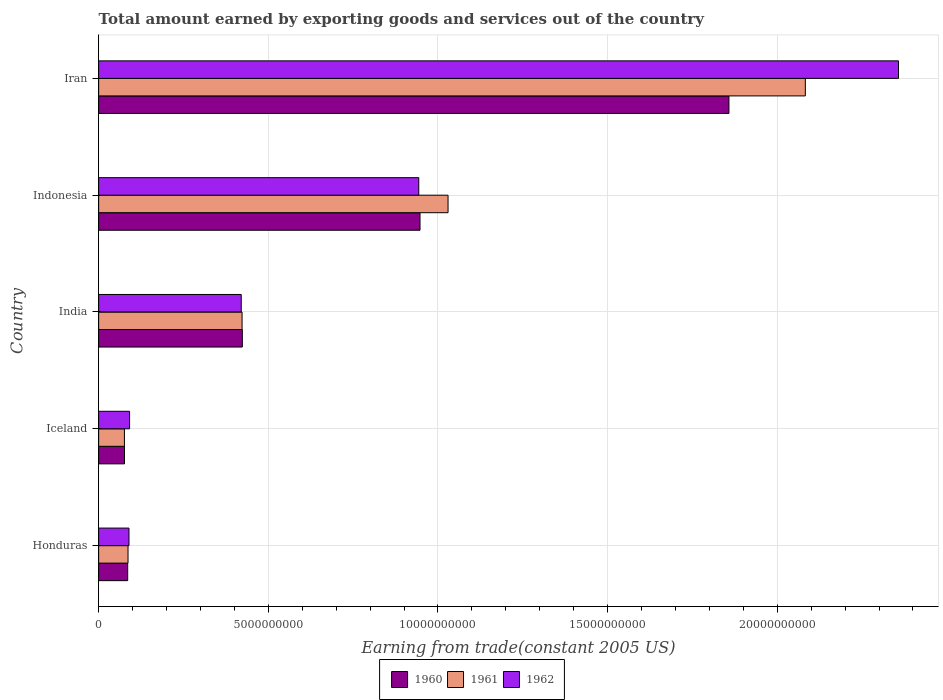Are the number of bars per tick equal to the number of legend labels?
Ensure brevity in your answer.  Yes. In how many cases, is the number of bars for a given country not equal to the number of legend labels?
Your response must be concise. 0. What is the total amount earned by exporting goods and services in 1962 in Honduras?
Provide a short and direct response. 8.95e+08. Across all countries, what is the maximum total amount earned by exporting goods and services in 1962?
Give a very brief answer. 2.36e+1. Across all countries, what is the minimum total amount earned by exporting goods and services in 1961?
Your answer should be very brief. 7.60e+08. In which country was the total amount earned by exporting goods and services in 1962 maximum?
Keep it short and to the point. Iran. What is the total total amount earned by exporting goods and services in 1960 in the graph?
Offer a terse response. 3.39e+1. What is the difference between the total amount earned by exporting goods and services in 1962 in Indonesia and that in Iran?
Provide a short and direct response. -1.41e+1. What is the difference between the total amount earned by exporting goods and services in 1960 in India and the total amount earned by exporting goods and services in 1962 in Iran?
Offer a terse response. -1.93e+1. What is the average total amount earned by exporting goods and services in 1962 per country?
Make the answer very short. 7.80e+09. What is the difference between the total amount earned by exporting goods and services in 1961 and total amount earned by exporting goods and services in 1962 in Honduras?
Offer a terse response. -2.82e+07. What is the ratio of the total amount earned by exporting goods and services in 1960 in Iceland to that in Iran?
Give a very brief answer. 0.04. Is the total amount earned by exporting goods and services in 1960 in India less than that in Iran?
Provide a succinct answer. Yes. Is the difference between the total amount earned by exporting goods and services in 1961 in Honduras and Iran greater than the difference between the total amount earned by exporting goods and services in 1962 in Honduras and Iran?
Provide a succinct answer. Yes. What is the difference between the highest and the second highest total amount earned by exporting goods and services in 1960?
Provide a short and direct response. 9.10e+09. What is the difference between the highest and the lowest total amount earned by exporting goods and services in 1962?
Ensure brevity in your answer.  2.27e+1. In how many countries, is the total amount earned by exporting goods and services in 1962 greater than the average total amount earned by exporting goods and services in 1962 taken over all countries?
Your answer should be very brief. 2. Is the sum of the total amount earned by exporting goods and services in 1961 in Honduras and Iran greater than the maximum total amount earned by exporting goods and services in 1962 across all countries?
Provide a short and direct response. No. What does the 3rd bar from the bottom in India represents?
Your answer should be very brief. 1962. Is it the case that in every country, the sum of the total amount earned by exporting goods and services in 1960 and total amount earned by exporting goods and services in 1962 is greater than the total amount earned by exporting goods and services in 1961?
Make the answer very short. Yes. How many bars are there?
Make the answer very short. 15. How many countries are there in the graph?
Your answer should be very brief. 5. Does the graph contain grids?
Provide a succinct answer. Yes. How many legend labels are there?
Provide a succinct answer. 3. How are the legend labels stacked?
Ensure brevity in your answer.  Horizontal. What is the title of the graph?
Offer a very short reply. Total amount earned by exporting goods and services out of the country. Does "2004" appear as one of the legend labels in the graph?
Provide a short and direct response. No. What is the label or title of the X-axis?
Offer a terse response. Earning from trade(constant 2005 US). What is the label or title of the Y-axis?
Make the answer very short. Country. What is the Earning from trade(constant 2005 US) of 1960 in Honduras?
Offer a very short reply. 8.56e+08. What is the Earning from trade(constant 2005 US) in 1961 in Honduras?
Your response must be concise. 8.66e+08. What is the Earning from trade(constant 2005 US) of 1962 in Honduras?
Give a very brief answer. 8.95e+08. What is the Earning from trade(constant 2005 US) in 1960 in Iceland?
Keep it short and to the point. 7.62e+08. What is the Earning from trade(constant 2005 US) in 1961 in Iceland?
Give a very brief answer. 7.60e+08. What is the Earning from trade(constant 2005 US) in 1962 in Iceland?
Your response must be concise. 9.12e+08. What is the Earning from trade(constant 2005 US) of 1960 in India?
Offer a terse response. 4.24e+09. What is the Earning from trade(constant 2005 US) in 1961 in India?
Your response must be concise. 4.23e+09. What is the Earning from trade(constant 2005 US) in 1962 in India?
Your response must be concise. 4.20e+09. What is the Earning from trade(constant 2005 US) of 1960 in Indonesia?
Give a very brief answer. 9.47e+09. What is the Earning from trade(constant 2005 US) of 1961 in Indonesia?
Your answer should be compact. 1.03e+1. What is the Earning from trade(constant 2005 US) of 1962 in Indonesia?
Your answer should be compact. 9.44e+09. What is the Earning from trade(constant 2005 US) of 1960 in Iran?
Provide a succinct answer. 1.86e+1. What is the Earning from trade(constant 2005 US) of 1961 in Iran?
Make the answer very short. 2.08e+1. What is the Earning from trade(constant 2005 US) of 1962 in Iran?
Provide a succinct answer. 2.36e+1. Across all countries, what is the maximum Earning from trade(constant 2005 US) of 1960?
Give a very brief answer. 1.86e+1. Across all countries, what is the maximum Earning from trade(constant 2005 US) in 1961?
Your answer should be very brief. 2.08e+1. Across all countries, what is the maximum Earning from trade(constant 2005 US) of 1962?
Keep it short and to the point. 2.36e+1. Across all countries, what is the minimum Earning from trade(constant 2005 US) of 1960?
Provide a short and direct response. 7.62e+08. Across all countries, what is the minimum Earning from trade(constant 2005 US) of 1961?
Provide a short and direct response. 7.60e+08. Across all countries, what is the minimum Earning from trade(constant 2005 US) of 1962?
Provide a short and direct response. 8.95e+08. What is the total Earning from trade(constant 2005 US) of 1960 in the graph?
Ensure brevity in your answer.  3.39e+1. What is the total Earning from trade(constant 2005 US) in 1961 in the graph?
Offer a terse response. 3.70e+1. What is the total Earning from trade(constant 2005 US) in 1962 in the graph?
Your answer should be very brief. 3.90e+1. What is the difference between the Earning from trade(constant 2005 US) in 1960 in Honduras and that in Iceland?
Ensure brevity in your answer.  9.37e+07. What is the difference between the Earning from trade(constant 2005 US) in 1961 in Honduras and that in Iceland?
Offer a very short reply. 1.06e+08. What is the difference between the Earning from trade(constant 2005 US) of 1962 in Honduras and that in Iceland?
Your answer should be very brief. -1.79e+07. What is the difference between the Earning from trade(constant 2005 US) of 1960 in Honduras and that in India?
Your answer should be very brief. -3.38e+09. What is the difference between the Earning from trade(constant 2005 US) in 1961 in Honduras and that in India?
Offer a terse response. -3.36e+09. What is the difference between the Earning from trade(constant 2005 US) of 1962 in Honduras and that in India?
Your answer should be compact. -3.31e+09. What is the difference between the Earning from trade(constant 2005 US) in 1960 in Honduras and that in Indonesia?
Provide a succinct answer. -8.62e+09. What is the difference between the Earning from trade(constant 2005 US) in 1961 in Honduras and that in Indonesia?
Ensure brevity in your answer.  -9.43e+09. What is the difference between the Earning from trade(constant 2005 US) in 1962 in Honduras and that in Indonesia?
Keep it short and to the point. -8.54e+09. What is the difference between the Earning from trade(constant 2005 US) of 1960 in Honduras and that in Iran?
Your answer should be compact. -1.77e+1. What is the difference between the Earning from trade(constant 2005 US) in 1961 in Honduras and that in Iran?
Provide a short and direct response. -2.00e+1. What is the difference between the Earning from trade(constant 2005 US) of 1962 in Honduras and that in Iran?
Provide a short and direct response. -2.27e+1. What is the difference between the Earning from trade(constant 2005 US) of 1960 in Iceland and that in India?
Keep it short and to the point. -3.47e+09. What is the difference between the Earning from trade(constant 2005 US) in 1961 in Iceland and that in India?
Offer a very short reply. -3.47e+09. What is the difference between the Earning from trade(constant 2005 US) of 1962 in Iceland and that in India?
Make the answer very short. -3.29e+09. What is the difference between the Earning from trade(constant 2005 US) of 1960 in Iceland and that in Indonesia?
Offer a terse response. -8.71e+09. What is the difference between the Earning from trade(constant 2005 US) of 1961 in Iceland and that in Indonesia?
Your answer should be compact. -9.54e+09. What is the difference between the Earning from trade(constant 2005 US) of 1962 in Iceland and that in Indonesia?
Offer a terse response. -8.52e+09. What is the difference between the Earning from trade(constant 2005 US) of 1960 in Iceland and that in Iran?
Your answer should be very brief. -1.78e+1. What is the difference between the Earning from trade(constant 2005 US) of 1961 in Iceland and that in Iran?
Make the answer very short. -2.01e+1. What is the difference between the Earning from trade(constant 2005 US) of 1962 in Iceland and that in Iran?
Ensure brevity in your answer.  -2.27e+1. What is the difference between the Earning from trade(constant 2005 US) in 1960 in India and that in Indonesia?
Your answer should be very brief. -5.24e+09. What is the difference between the Earning from trade(constant 2005 US) of 1961 in India and that in Indonesia?
Give a very brief answer. -6.07e+09. What is the difference between the Earning from trade(constant 2005 US) in 1962 in India and that in Indonesia?
Provide a short and direct response. -5.23e+09. What is the difference between the Earning from trade(constant 2005 US) of 1960 in India and that in Iran?
Keep it short and to the point. -1.43e+1. What is the difference between the Earning from trade(constant 2005 US) of 1961 in India and that in Iran?
Provide a succinct answer. -1.66e+1. What is the difference between the Earning from trade(constant 2005 US) of 1962 in India and that in Iran?
Offer a terse response. -1.94e+1. What is the difference between the Earning from trade(constant 2005 US) in 1960 in Indonesia and that in Iran?
Ensure brevity in your answer.  -9.10e+09. What is the difference between the Earning from trade(constant 2005 US) in 1961 in Indonesia and that in Iran?
Your answer should be very brief. -1.05e+1. What is the difference between the Earning from trade(constant 2005 US) of 1962 in Indonesia and that in Iran?
Provide a short and direct response. -1.41e+1. What is the difference between the Earning from trade(constant 2005 US) in 1960 in Honduras and the Earning from trade(constant 2005 US) in 1961 in Iceland?
Ensure brevity in your answer.  9.63e+07. What is the difference between the Earning from trade(constant 2005 US) of 1960 in Honduras and the Earning from trade(constant 2005 US) of 1962 in Iceland?
Your response must be concise. -5.63e+07. What is the difference between the Earning from trade(constant 2005 US) of 1961 in Honduras and the Earning from trade(constant 2005 US) of 1962 in Iceland?
Your answer should be very brief. -4.61e+07. What is the difference between the Earning from trade(constant 2005 US) in 1960 in Honduras and the Earning from trade(constant 2005 US) in 1961 in India?
Keep it short and to the point. -3.37e+09. What is the difference between the Earning from trade(constant 2005 US) of 1960 in Honduras and the Earning from trade(constant 2005 US) of 1962 in India?
Ensure brevity in your answer.  -3.35e+09. What is the difference between the Earning from trade(constant 2005 US) in 1961 in Honduras and the Earning from trade(constant 2005 US) in 1962 in India?
Make the answer very short. -3.34e+09. What is the difference between the Earning from trade(constant 2005 US) of 1960 in Honduras and the Earning from trade(constant 2005 US) of 1961 in Indonesia?
Ensure brevity in your answer.  -9.44e+09. What is the difference between the Earning from trade(constant 2005 US) in 1960 in Honduras and the Earning from trade(constant 2005 US) in 1962 in Indonesia?
Your answer should be compact. -8.58e+09. What is the difference between the Earning from trade(constant 2005 US) of 1961 in Honduras and the Earning from trade(constant 2005 US) of 1962 in Indonesia?
Your answer should be very brief. -8.57e+09. What is the difference between the Earning from trade(constant 2005 US) of 1960 in Honduras and the Earning from trade(constant 2005 US) of 1961 in Iran?
Give a very brief answer. -2.00e+1. What is the difference between the Earning from trade(constant 2005 US) in 1960 in Honduras and the Earning from trade(constant 2005 US) in 1962 in Iran?
Your answer should be compact. -2.27e+1. What is the difference between the Earning from trade(constant 2005 US) of 1961 in Honduras and the Earning from trade(constant 2005 US) of 1962 in Iran?
Give a very brief answer. -2.27e+1. What is the difference between the Earning from trade(constant 2005 US) of 1960 in Iceland and the Earning from trade(constant 2005 US) of 1961 in India?
Your response must be concise. -3.46e+09. What is the difference between the Earning from trade(constant 2005 US) of 1960 in Iceland and the Earning from trade(constant 2005 US) of 1962 in India?
Offer a very short reply. -3.44e+09. What is the difference between the Earning from trade(constant 2005 US) in 1961 in Iceland and the Earning from trade(constant 2005 US) in 1962 in India?
Your response must be concise. -3.44e+09. What is the difference between the Earning from trade(constant 2005 US) in 1960 in Iceland and the Earning from trade(constant 2005 US) in 1961 in Indonesia?
Keep it short and to the point. -9.54e+09. What is the difference between the Earning from trade(constant 2005 US) in 1960 in Iceland and the Earning from trade(constant 2005 US) in 1962 in Indonesia?
Provide a short and direct response. -8.67e+09. What is the difference between the Earning from trade(constant 2005 US) of 1961 in Iceland and the Earning from trade(constant 2005 US) of 1962 in Indonesia?
Your answer should be very brief. -8.68e+09. What is the difference between the Earning from trade(constant 2005 US) of 1960 in Iceland and the Earning from trade(constant 2005 US) of 1961 in Iran?
Offer a very short reply. -2.01e+1. What is the difference between the Earning from trade(constant 2005 US) of 1960 in Iceland and the Earning from trade(constant 2005 US) of 1962 in Iran?
Make the answer very short. -2.28e+1. What is the difference between the Earning from trade(constant 2005 US) of 1961 in Iceland and the Earning from trade(constant 2005 US) of 1962 in Iran?
Provide a short and direct response. -2.28e+1. What is the difference between the Earning from trade(constant 2005 US) of 1960 in India and the Earning from trade(constant 2005 US) of 1961 in Indonesia?
Your response must be concise. -6.06e+09. What is the difference between the Earning from trade(constant 2005 US) in 1960 in India and the Earning from trade(constant 2005 US) in 1962 in Indonesia?
Keep it short and to the point. -5.20e+09. What is the difference between the Earning from trade(constant 2005 US) of 1961 in India and the Earning from trade(constant 2005 US) of 1962 in Indonesia?
Ensure brevity in your answer.  -5.21e+09. What is the difference between the Earning from trade(constant 2005 US) in 1960 in India and the Earning from trade(constant 2005 US) in 1961 in Iran?
Offer a terse response. -1.66e+1. What is the difference between the Earning from trade(constant 2005 US) in 1960 in India and the Earning from trade(constant 2005 US) in 1962 in Iran?
Make the answer very short. -1.93e+1. What is the difference between the Earning from trade(constant 2005 US) of 1961 in India and the Earning from trade(constant 2005 US) of 1962 in Iran?
Make the answer very short. -1.93e+1. What is the difference between the Earning from trade(constant 2005 US) of 1960 in Indonesia and the Earning from trade(constant 2005 US) of 1961 in Iran?
Make the answer very short. -1.14e+1. What is the difference between the Earning from trade(constant 2005 US) of 1960 in Indonesia and the Earning from trade(constant 2005 US) of 1962 in Iran?
Ensure brevity in your answer.  -1.41e+1. What is the difference between the Earning from trade(constant 2005 US) of 1961 in Indonesia and the Earning from trade(constant 2005 US) of 1962 in Iran?
Provide a succinct answer. -1.33e+1. What is the average Earning from trade(constant 2005 US) in 1960 per country?
Your answer should be very brief. 6.78e+09. What is the average Earning from trade(constant 2005 US) in 1961 per country?
Your response must be concise. 7.40e+09. What is the average Earning from trade(constant 2005 US) in 1962 per country?
Your answer should be compact. 7.80e+09. What is the difference between the Earning from trade(constant 2005 US) in 1960 and Earning from trade(constant 2005 US) in 1961 in Honduras?
Your answer should be compact. -1.02e+07. What is the difference between the Earning from trade(constant 2005 US) of 1960 and Earning from trade(constant 2005 US) of 1962 in Honduras?
Provide a short and direct response. -3.84e+07. What is the difference between the Earning from trade(constant 2005 US) in 1961 and Earning from trade(constant 2005 US) in 1962 in Honduras?
Ensure brevity in your answer.  -2.82e+07. What is the difference between the Earning from trade(constant 2005 US) of 1960 and Earning from trade(constant 2005 US) of 1961 in Iceland?
Provide a short and direct response. 2.61e+06. What is the difference between the Earning from trade(constant 2005 US) of 1960 and Earning from trade(constant 2005 US) of 1962 in Iceland?
Provide a short and direct response. -1.50e+08. What is the difference between the Earning from trade(constant 2005 US) of 1961 and Earning from trade(constant 2005 US) of 1962 in Iceland?
Provide a succinct answer. -1.53e+08. What is the difference between the Earning from trade(constant 2005 US) of 1960 and Earning from trade(constant 2005 US) of 1961 in India?
Your response must be concise. 7.87e+06. What is the difference between the Earning from trade(constant 2005 US) in 1960 and Earning from trade(constant 2005 US) in 1962 in India?
Your response must be concise. 3.24e+07. What is the difference between the Earning from trade(constant 2005 US) in 1961 and Earning from trade(constant 2005 US) in 1962 in India?
Keep it short and to the point. 2.45e+07. What is the difference between the Earning from trade(constant 2005 US) in 1960 and Earning from trade(constant 2005 US) in 1961 in Indonesia?
Make the answer very short. -8.26e+08. What is the difference between the Earning from trade(constant 2005 US) in 1960 and Earning from trade(constant 2005 US) in 1962 in Indonesia?
Offer a very short reply. 3.67e+07. What is the difference between the Earning from trade(constant 2005 US) of 1961 and Earning from trade(constant 2005 US) of 1962 in Indonesia?
Your response must be concise. 8.63e+08. What is the difference between the Earning from trade(constant 2005 US) of 1960 and Earning from trade(constant 2005 US) of 1961 in Iran?
Give a very brief answer. -2.25e+09. What is the difference between the Earning from trade(constant 2005 US) in 1960 and Earning from trade(constant 2005 US) in 1962 in Iran?
Keep it short and to the point. -5.00e+09. What is the difference between the Earning from trade(constant 2005 US) in 1961 and Earning from trade(constant 2005 US) in 1962 in Iran?
Your response must be concise. -2.75e+09. What is the ratio of the Earning from trade(constant 2005 US) of 1960 in Honduras to that in Iceland?
Give a very brief answer. 1.12. What is the ratio of the Earning from trade(constant 2005 US) of 1961 in Honduras to that in Iceland?
Ensure brevity in your answer.  1.14. What is the ratio of the Earning from trade(constant 2005 US) in 1962 in Honduras to that in Iceland?
Keep it short and to the point. 0.98. What is the ratio of the Earning from trade(constant 2005 US) in 1960 in Honduras to that in India?
Ensure brevity in your answer.  0.2. What is the ratio of the Earning from trade(constant 2005 US) of 1961 in Honduras to that in India?
Make the answer very short. 0.2. What is the ratio of the Earning from trade(constant 2005 US) of 1962 in Honduras to that in India?
Provide a short and direct response. 0.21. What is the ratio of the Earning from trade(constant 2005 US) in 1960 in Honduras to that in Indonesia?
Give a very brief answer. 0.09. What is the ratio of the Earning from trade(constant 2005 US) of 1961 in Honduras to that in Indonesia?
Your answer should be very brief. 0.08. What is the ratio of the Earning from trade(constant 2005 US) in 1962 in Honduras to that in Indonesia?
Your answer should be very brief. 0.09. What is the ratio of the Earning from trade(constant 2005 US) in 1960 in Honduras to that in Iran?
Your response must be concise. 0.05. What is the ratio of the Earning from trade(constant 2005 US) of 1961 in Honduras to that in Iran?
Provide a short and direct response. 0.04. What is the ratio of the Earning from trade(constant 2005 US) of 1962 in Honduras to that in Iran?
Offer a terse response. 0.04. What is the ratio of the Earning from trade(constant 2005 US) in 1960 in Iceland to that in India?
Your response must be concise. 0.18. What is the ratio of the Earning from trade(constant 2005 US) in 1961 in Iceland to that in India?
Make the answer very short. 0.18. What is the ratio of the Earning from trade(constant 2005 US) of 1962 in Iceland to that in India?
Ensure brevity in your answer.  0.22. What is the ratio of the Earning from trade(constant 2005 US) in 1960 in Iceland to that in Indonesia?
Your answer should be very brief. 0.08. What is the ratio of the Earning from trade(constant 2005 US) of 1961 in Iceland to that in Indonesia?
Give a very brief answer. 0.07. What is the ratio of the Earning from trade(constant 2005 US) of 1962 in Iceland to that in Indonesia?
Your answer should be compact. 0.1. What is the ratio of the Earning from trade(constant 2005 US) of 1960 in Iceland to that in Iran?
Give a very brief answer. 0.04. What is the ratio of the Earning from trade(constant 2005 US) of 1961 in Iceland to that in Iran?
Offer a very short reply. 0.04. What is the ratio of the Earning from trade(constant 2005 US) in 1962 in Iceland to that in Iran?
Keep it short and to the point. 0.04. What is the ratio of the Earning from trade(constant 2005 US) of 1960 in India to that in Indonesia?
Your response must be concise. 0.45. What is the ratio of the Earning from trade(constant 2005 US) of 1961 in India to that in Indonesia?
Provide a succinct answer. 0.41. What is the ratio of the Earning from trade(constant 2005 US) of 1962 in India to that in Indonesia?
Keep it short and to the point. 0.45. What is the ratio of the Earning from trade(constant 2005 US) of 1960 in India to that in Iran?
Offer a terse response. 0.23. What is the ratio of the Earning from trade(constant 2005 US) of 1961 in India to that in Iran?
Make the answer very short. 0.2. What is the ratio of the Earning from trade(constant 2005 US) of 1962 in India to that in Iran?
Your answer should be very brief. 0.18. What is the ratio of the Earning from trade(constant 2005 US) in 1960 in Indonesia to that in Iran?
Your answer should be very brief. 0.51. What is the ratio of the Earning from trade(constant 2005 US) of 1961 in Indonesia to that in Iran?
Your answer should be compact. 0.49. What is the ratio of the Earning from trade(constant 2005 US) in 1962 in Indonesia to that in Iran?
Offer a terse response. 0.4. What is the difference between the highest and the second highest Earning from trade(constant 2005 US) of 1960?
Give a very brief answer. 9.10e+09. What is the difference between the highest and the second highest Earning from trade(constant 2005 US) of 1961?
Ensure brevity in your answer.  1.05e+1. What is the difference between the highest and the second highest Earning from trade(constant 2005 US) of 1962?
Keep it short and to the point. 1.41e+1. What is the difference between the highest and the lowest Earning from trade(constant 2005 US) in 1960?
Provide a short and direct response. 1.78e+1. What is the difference between the highest and the lowest Earning from trade(constant 2005 US) in 1961?
Give a very brief answer. 2.01e+1. What is the difference between the highest and the lowest Earning from trade(constant 2005 US) of 1962?
Offer a terse response. 2.27e+1. 